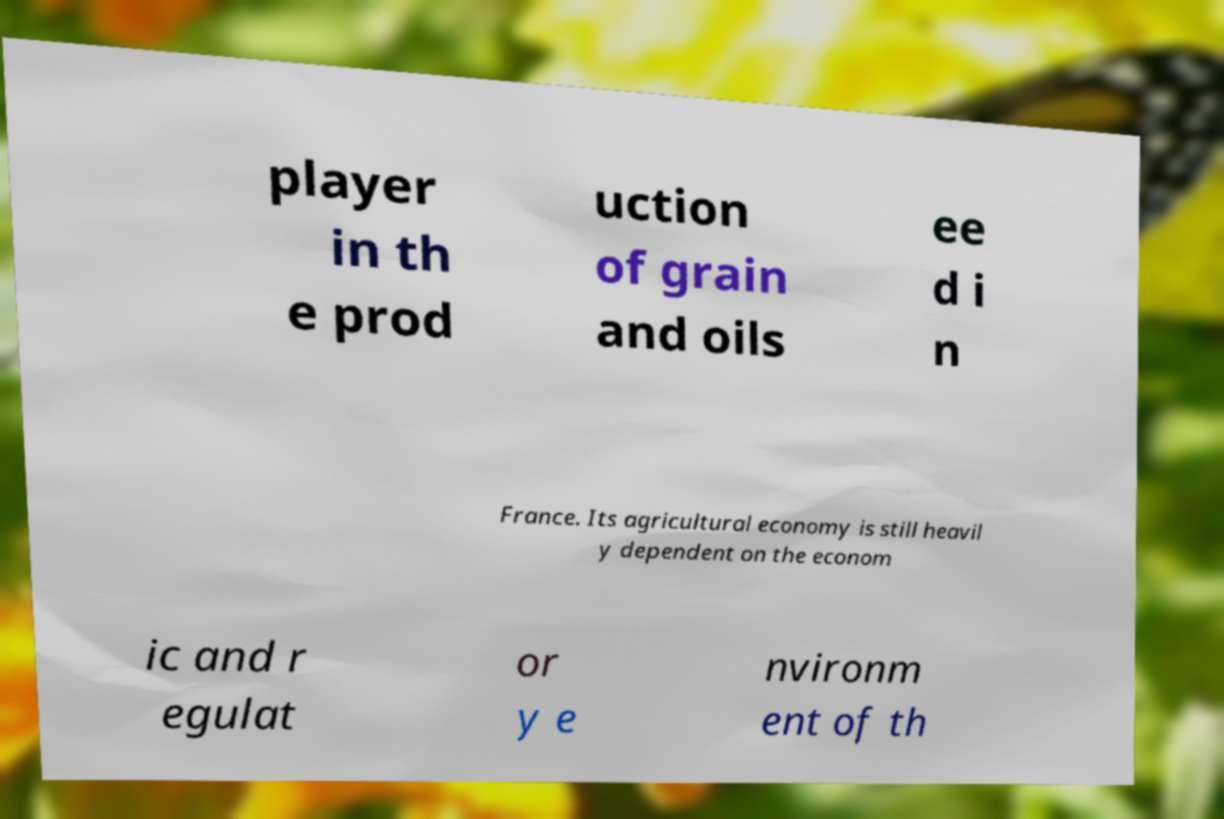I need the written content from this picture converted into text. Can you do that? player in th e prod uction of grain and oils ee d i n France. Its agricultural economy is still heavil y dependent on the econom ic and r egulat or y e nvironm ent of th 